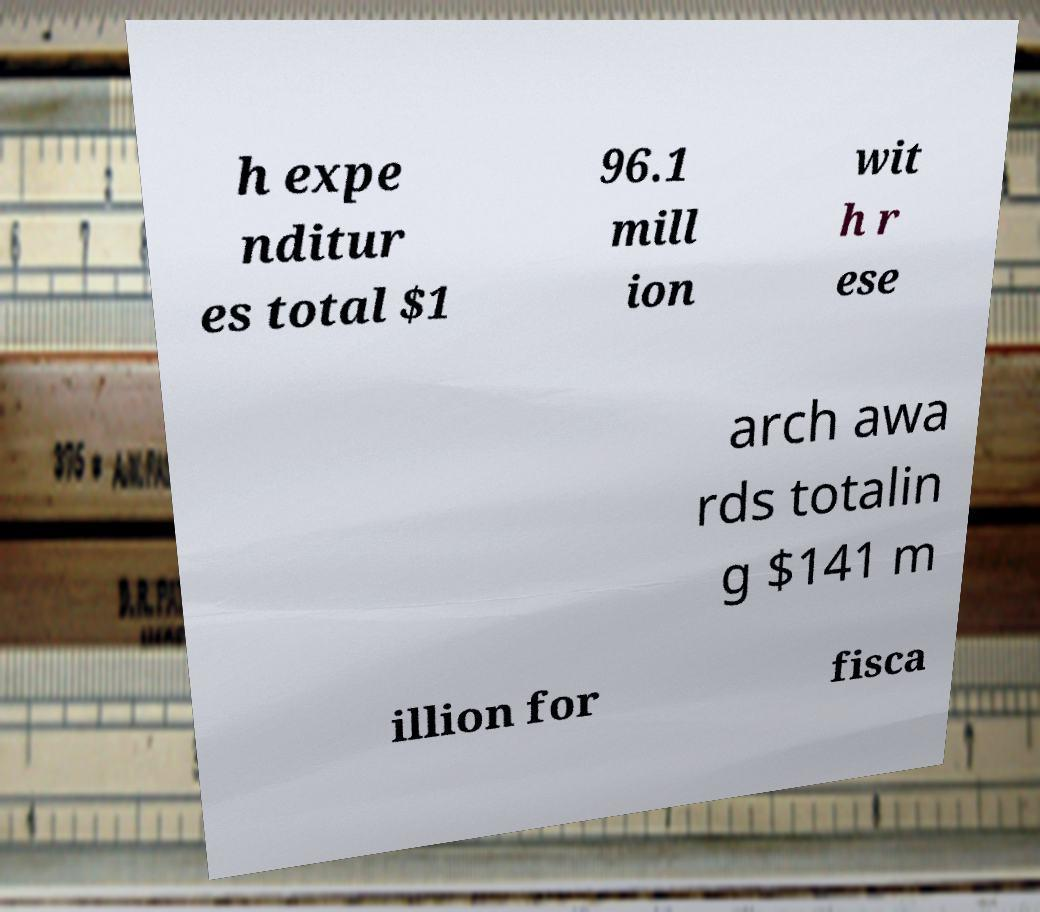Please read and relay the text visible in this image. What does it say? h expe nditur es total $1 96.1 mill ion wit h r ese arch awa rds totalin g $141 m illion for fisca 